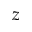<formula> <loc_0><loc_0><loc_500><loc_500>z</formula> 